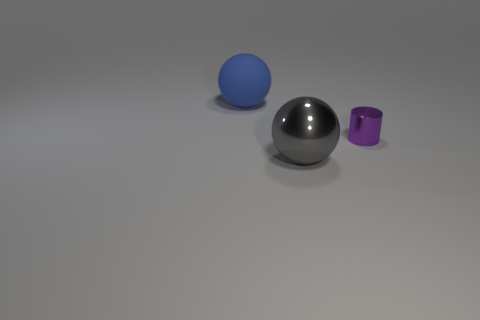What is the shape of the object that is in front of the big blue matte thing and on the left side of the tiny purple object?
Your answer should be compact. Sphere. The ball that is the same size as the blue thing is what color?
Your answer should be compact. Gray. Is the matte ball the same size as the cylinder?
Provide a succinct answer. No. There is a small purple metallic thing; how many small purple metallic things are behind it?
Offer a terse response. 0. What number of things are either big objects that are left of the gray metallic sphere or large purple rubber cylinders?
Keep it short and to the point. 1. Are there more metal balls that are in front of the purple object than blue rubber things right of the gray ball?
Your answer should be compact. Yes. There is a matte thing; is its size the same as the ball that is in front of the purple shiny cylinder?
Offer a very short reply. Yes. How many cubes are blue matte things or big things?
Provide a succinct answer. 0. There is another thing that is made of the same material as the purple object; what is its size?
Make the answer very short. Large. Does the sphere in front of the tiny metal cylinder have the same size as the object on the left side of the gray metal ball?
Give a very brief answer. Yes. 